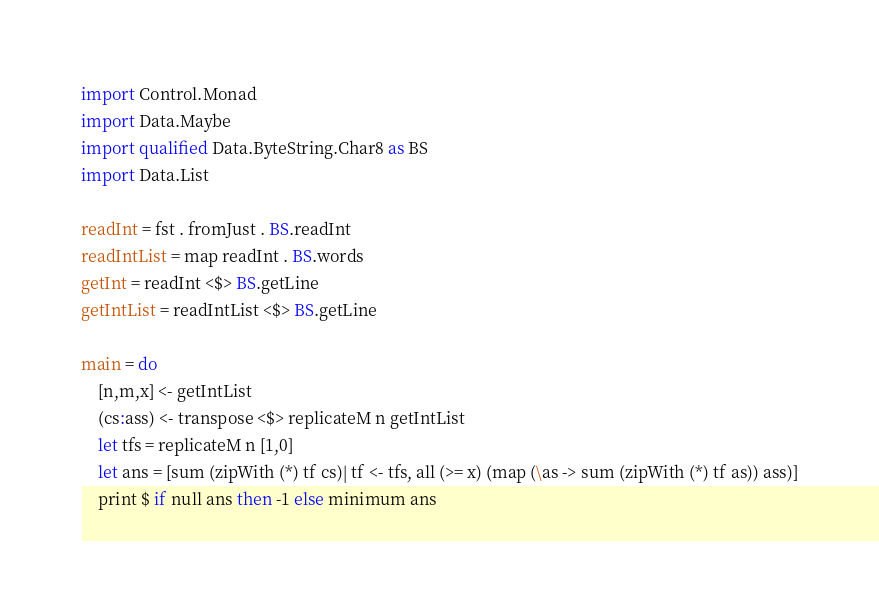<code> <loc_0><loc_0><loc_500><loc_500><_Haskell_>import Control.Monad
import Data.Maybe
import qualified Data.ByteString.Char8 as BS
import Data.List

readInt = fst . fromJust . BS.readInt
readIntList = map readInt . BS.words
getInt = readInt <$> BS.getLine
getIntList = readIntList <$> BS.getLine

main = do
    [n,m,x] <- getIntList
    (cs:ass) <- transpose <$> replicateM n getIntList
    let tfs = replicateM n [1,0]
    let ans = [sum (zipWith (*) tf cs)| tf <- tfs, all (>= x) (map (\as -> sum (zipWith (*) tf as)) ass)]
    print $ if null ans then -1 else minimum ans</code> 